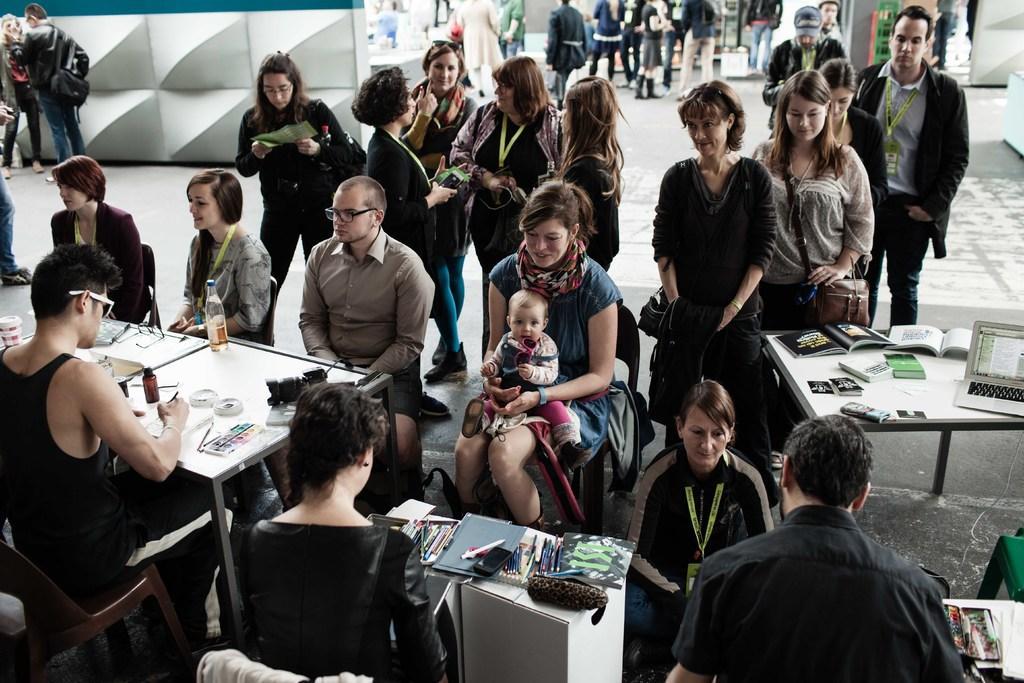Please provide a concise description of this image. In this image there are group of people some of them are sitting and some of them are standing and talking with each other. On the left side of the bottom there is one table on the table there are some papers and bottles are there. On the right side there is another table and on that table there are books, laptop are there in the middle there is one table, on the table there is one book and pens are there. 